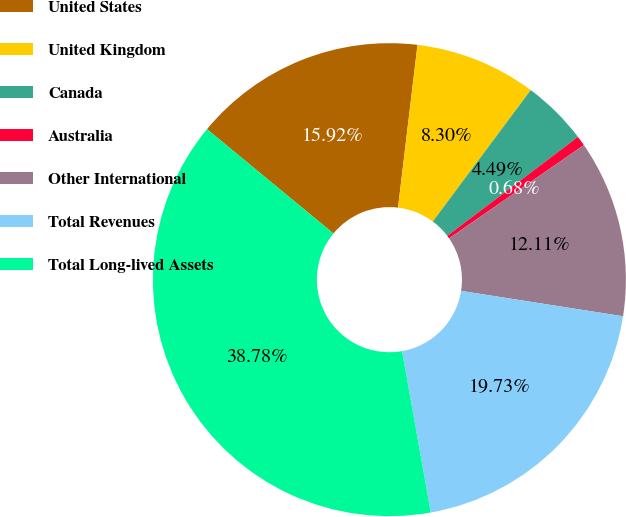<chart> <loc_0><loc_0><loc_500><loc_500><pie_chart><fcel>United States<fcel>United Kingdom<fcel>Canada<fcel>Australia<fcel>Other International<fcel>Total Revenues<fcel>Total Long-lived Assets<nl><fcel>15.92%<fcel>8.3%<fcel>4.49%<fcel>0.68%<fcel>12.11%<fcel>19.73%<fcel>38.78%<nl></chart> 